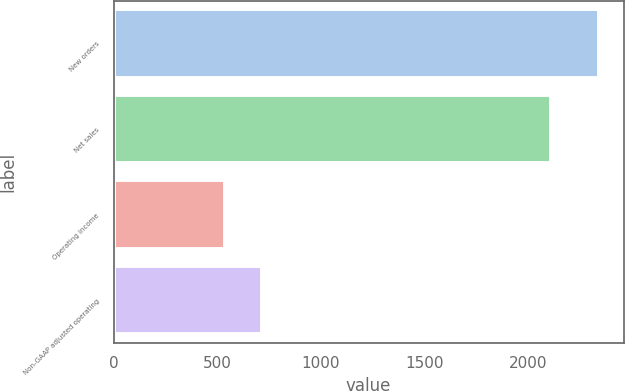Convert chart to OTSL. <chart><loc_0><loc_0><loc_500><loc_500><bar_chart><fcel>New orders<fcel>Net sales<fcel>Operating income<fcel>Non-GAAP adjusted operating<nl><fcel>2345<fcel>2114<fcel>538<fcel>718.7<nl></chart> 